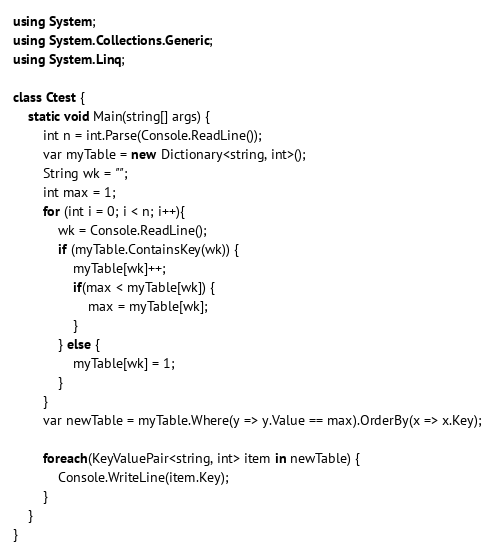Convert code to text. <code><loc_0><loc_0><loc_500><loc_500><_C#_>using System;
using System.Collections.Generic;
using System.Linq;
 
class Ctest {
    static void Main(string[] args) {
        int n = int.Parse(Console.ReadLine());
        var myTable = new Dictionary<string, int>();
        String wk = "";
        int max = 1;
        for (int i = 0; i < n; i++){
            wk = Console.ReadLine();
            if (myTable.ContainsKey(wk)) {
                myTable[wk]++;
                if(max < myTable[wk]) {
                    max = myTable[wk];
                }
            } else {
                myTable[wk] = 1;
            }
        }
        var newTable = myTable.Where(y => y.Value == max).OrderBy(x => x.Key);
      
        foreach(KeyValuePair<string, int> item in newTable) {
            Console.WriteLine(item.Key);
        }
    }
}</code> 